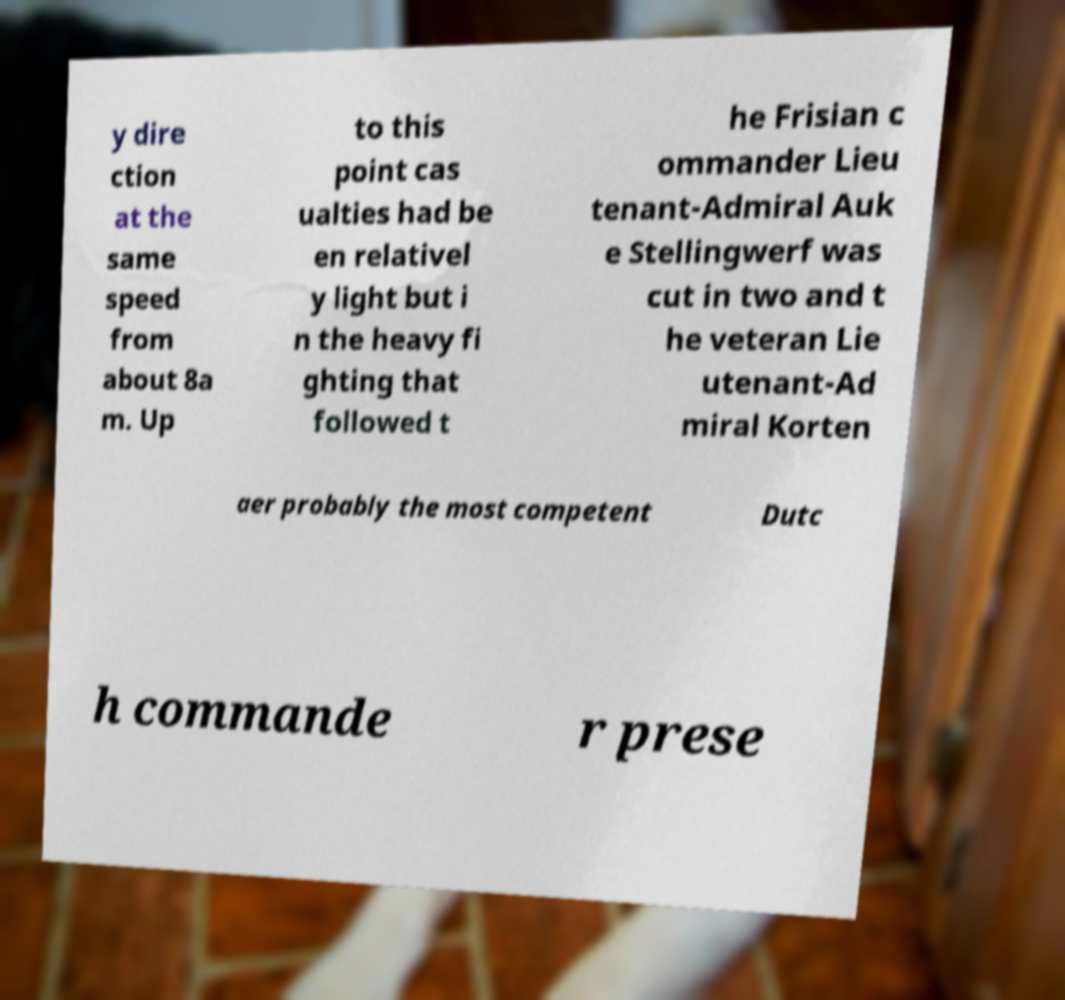Can you read and provide the text displayed in the image?This photo seems to have some interesting text. Can you extract and type it out for me? y dire ction at the same speed from about 8a m. Up to this point cas ualties had be en relativel y light but i n the heavy fi ghting that followed t he Frisian c ommander Lieu tenant-Admiral Auk e Stellingwerf was cut in two and t he veteran Lie utenant-Ad miral Korten aer probably the most competent Dutc h commande r prese 